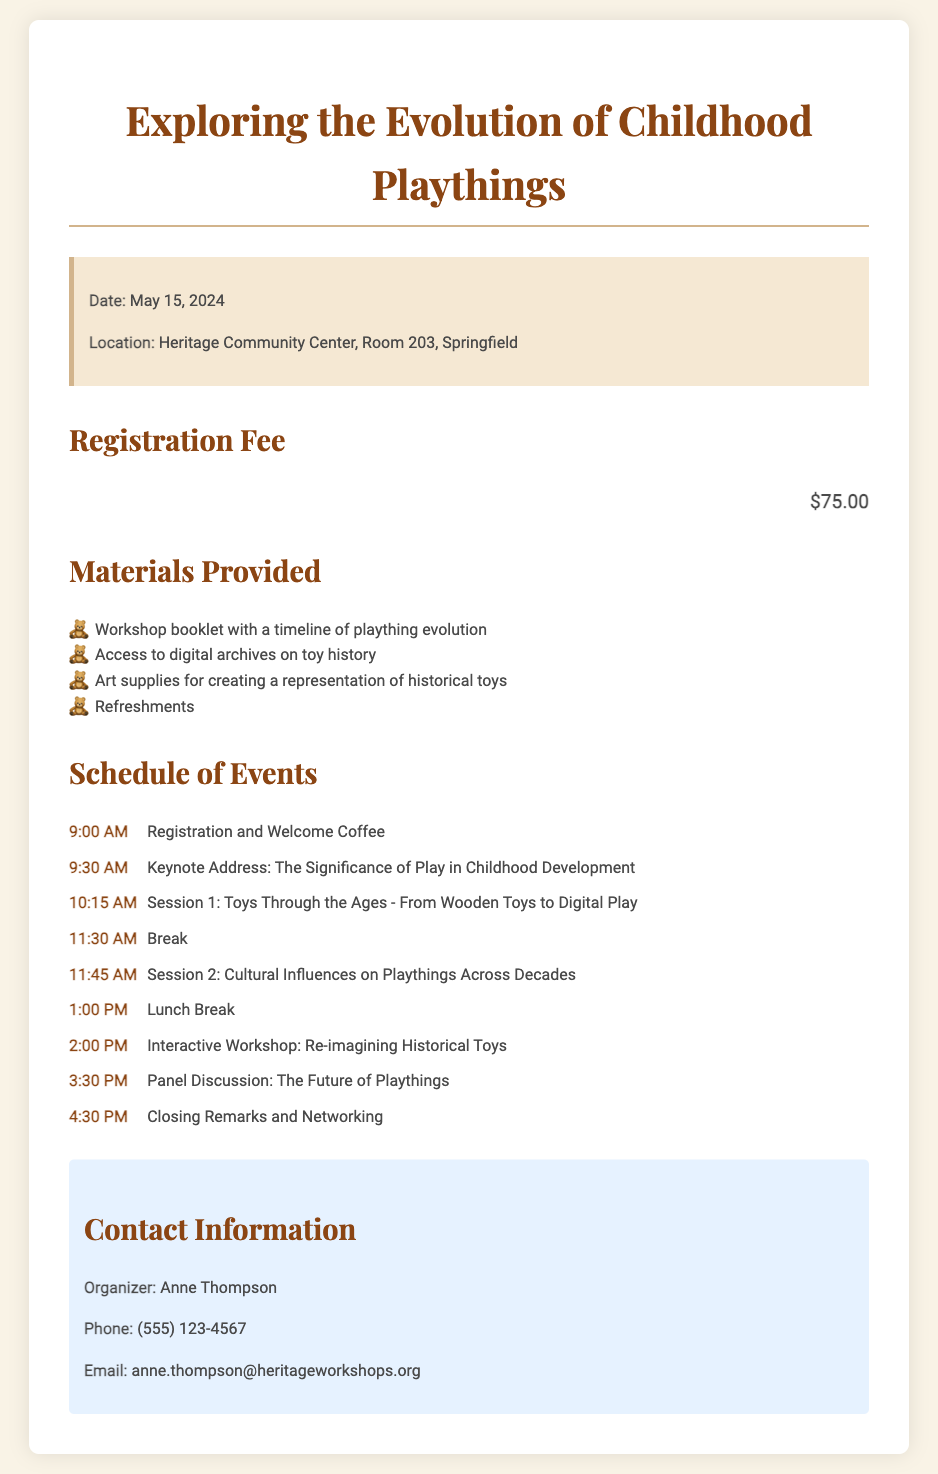What is the date of the workshop? The date of the workshop is clearly stated in the document under the info block.
Answer: May 15, 2024 What is the location of the event? The location of the workshop is mentioned directly in the info block section.
Answer: Heritage Community Center, Room 203, Springfield What is the registration fee? The registration fee is highlighted under its own section for easy retrieval.
Answer: $75.00 Who is the organizer of the workshop? The organizer's name is provided in the contact information section.
Answer: Anne Thompson What is the first session topic? The first session topic is listed in the schedule of events with its corresponding time.
Answer: Toys Through the Ages - From Wooden Toys to Digital Play How many materials are provided? The materials provided are listed in a bulleted format, which allows for easy counting.
Answer: Four What time does the first session start? The beginning time of the first session can be found in the schedule section.
Answer: 10:15 AM What is included in the materials provided? Several items are noted in the bulleted list under "Materials Provided."
Answer: Workshop booklet with a timeline of plaything evolution What is the last scheduled event of the day? The closing event is explicitly stated in the schedule section of the document.
Answer: Closing Remarks and Networking 